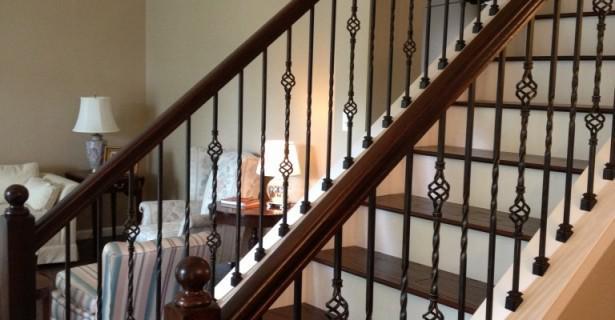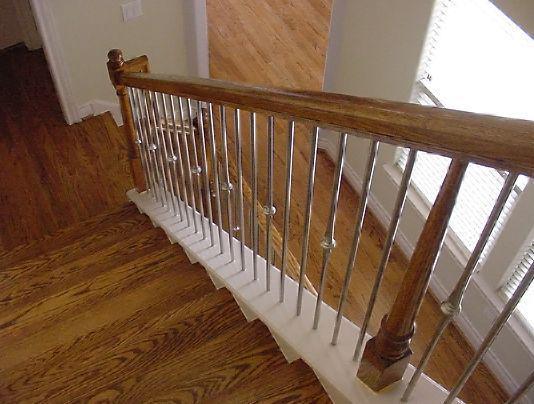The first image is the image on the left, the second image is the image on the right. Evaluate the accuracy of this statement regarding the images: "One of the stairways curves, while the other stairway has straight sections.". Is it true? Answer yes or no. No. The first image is the image on the left, the second image is the image on the right. Given the left and right images, does the statement "Each image features a non-curved staircase with wooden handrails and wrought iron bars that feature some dimensional decorative element." hold true? Answer yes or no. Yes. 